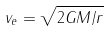Convert formula to latex. <formula><loc_0><loc_0><loc_500><loc_500>v _ { e } = \sqrt { 2 G M / r }</formula> 